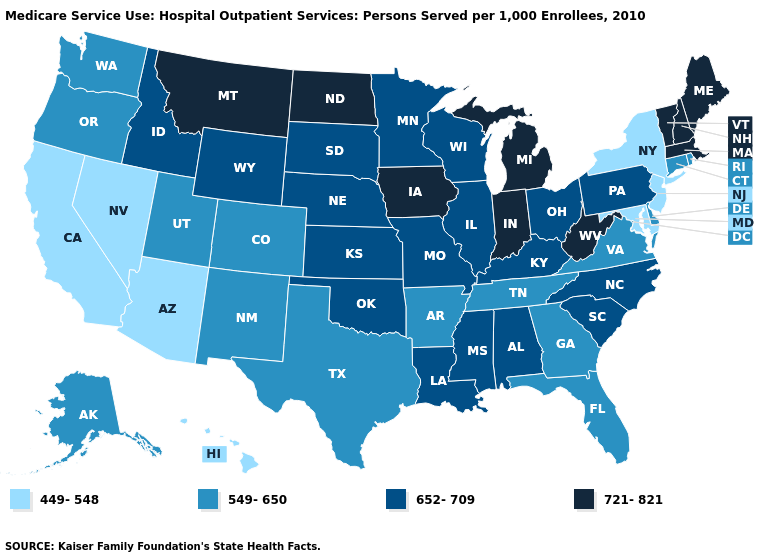Among the states that border Vermont , does New Hampshire have the highest value?
Quick response, please. Yes. Does the first symbol in the legend represent the smallest category?
Answer briefly. Yes. Does New Jersey have a lower value than Washington?
Short answer required. Yes. Name the states that have a value in the range 549-650?
Be succinct. Alaska, Arkansas, Colorado, Connecticut, Delaware, Florida, Georgia, New Mexico, Oregon, Rhode Island, Tennessee, Texas, Utah, Virginia, Washington. What is the lowest value in states that border Missouri?
Give a very brief answer. 549-650. Among the states that border Indiana , which have the highest value?
Quick response, please. Michigan. Name the states that have a value in the range 549-650?
Keep it brief. Alaska, Arkansas, Colorado, Connecticut, Delaware, Florida, Georgia, New Mexico, Oregon, Rhode Island, Tennessee, Texas, Utah, Virginia, Washington. Name the states that have a value in the range 549-650?
Short answer required. Alaska, Arkansas, Colorado, Connecticut, Delaware, Florida, Georgia, New Mexico, Oregon, Rhode Island, Tennessee, Texas, Utah, Virginia, Washington. Which states have the lowest value in the USA?
Keep it brief. Arizona, California, Hawaii, Maryland, Nevada, New Jersey, New York. What is the value of Florida?
Quick response, please. 549-650. Which states have the lowest value in the South?
Concise answer only. Maryland. Which states have the highest value in the USA?
Concise answer only. Indiana, Iowa, Maine, Massachusetts, Michigan, Montana, New Hampshire, North Dakota, Vermont, West Virginia. Does the map have missing data?
Short answer required. No. What is the value of Oklahoma?
Keep it brief. 652-709. How many symbols are there in the legend?
Answer briefly. 4. 